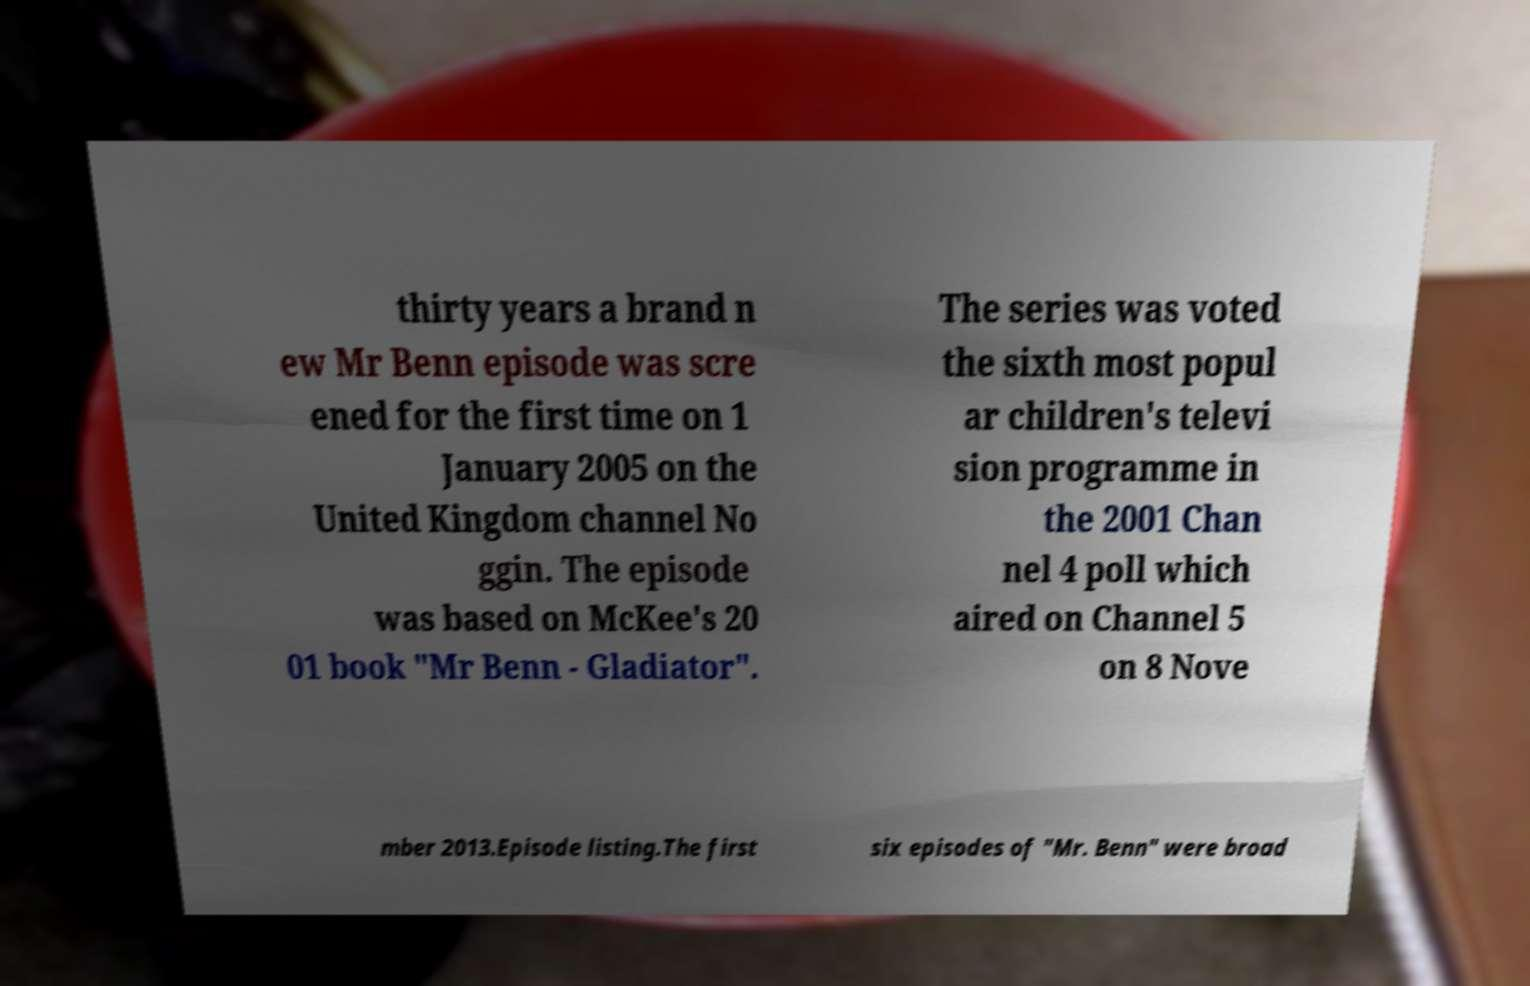I need the written content from this picture converted into text. Can you do that? thirty years a brand n ew Mr Benn episode was scre ened for the first time on 1 January 2005 on the United Kingdom channel No ggin. The episode was based on McKee's 20 01 book "Mr Benn - Gladiator". The series was voted the sixth most popul ar children's televi sion programme in the 2001 Chan nel 4 poll which aired on Channel 5 on 8 Nove mber 2013.Episode listing.The first six episodes of "Mr. Benn" were broad 